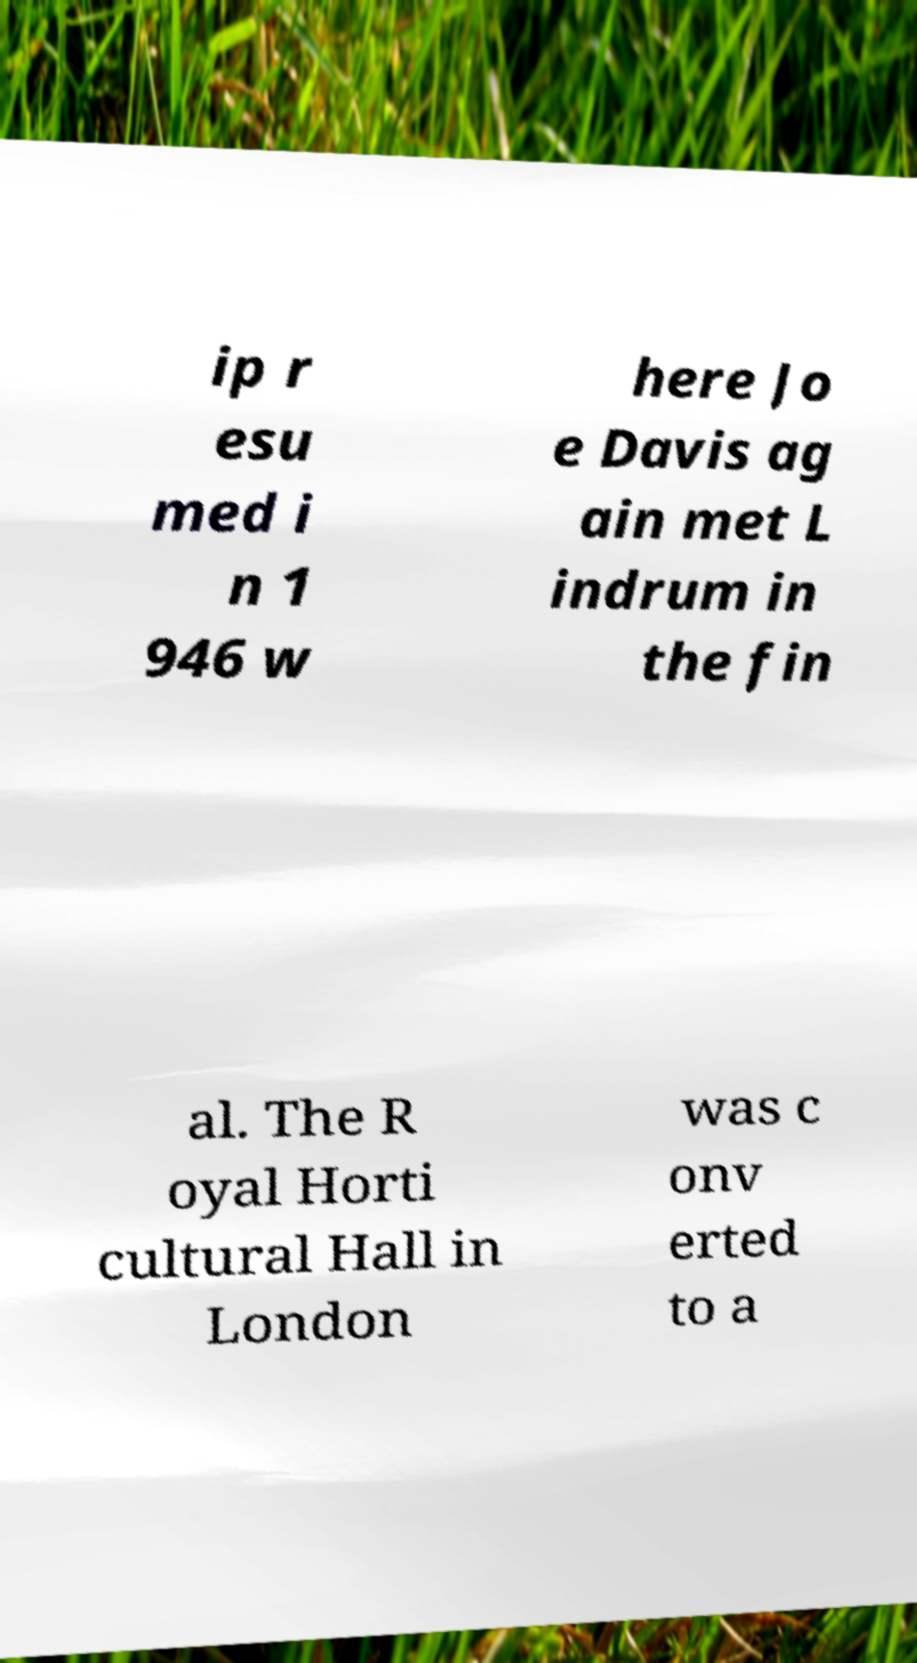Could you assist in decoding the text presented in this image and type it out clearly? ip r esu med i n 1 946 w here Jo e Davis ag ain met L indrum in the fin al. The R oyal Horti cultural Hall in London was c onv erted to a 